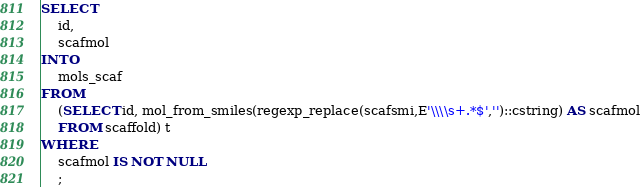Convert code to text. <code><loc_0><loc_0><loc_500><loc_500><_SQL_>SELECT
	id,
	scafmol
INTO
	mols_scaf
FROM
	(SELECT id, mol_from_smiles(regexp_replace(scafsmi,E'\\\\s+.*$','')::cstring) AS scafmol
	FROM scaffold) t
WHERE
	scafmol IS NOT NULL
	;
</code> 